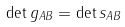Convert formula to latex. <formula><loc_0><loc_0><loc_500><loc_500>\det g _ { A B } = \det s _ { A B }</formula> 